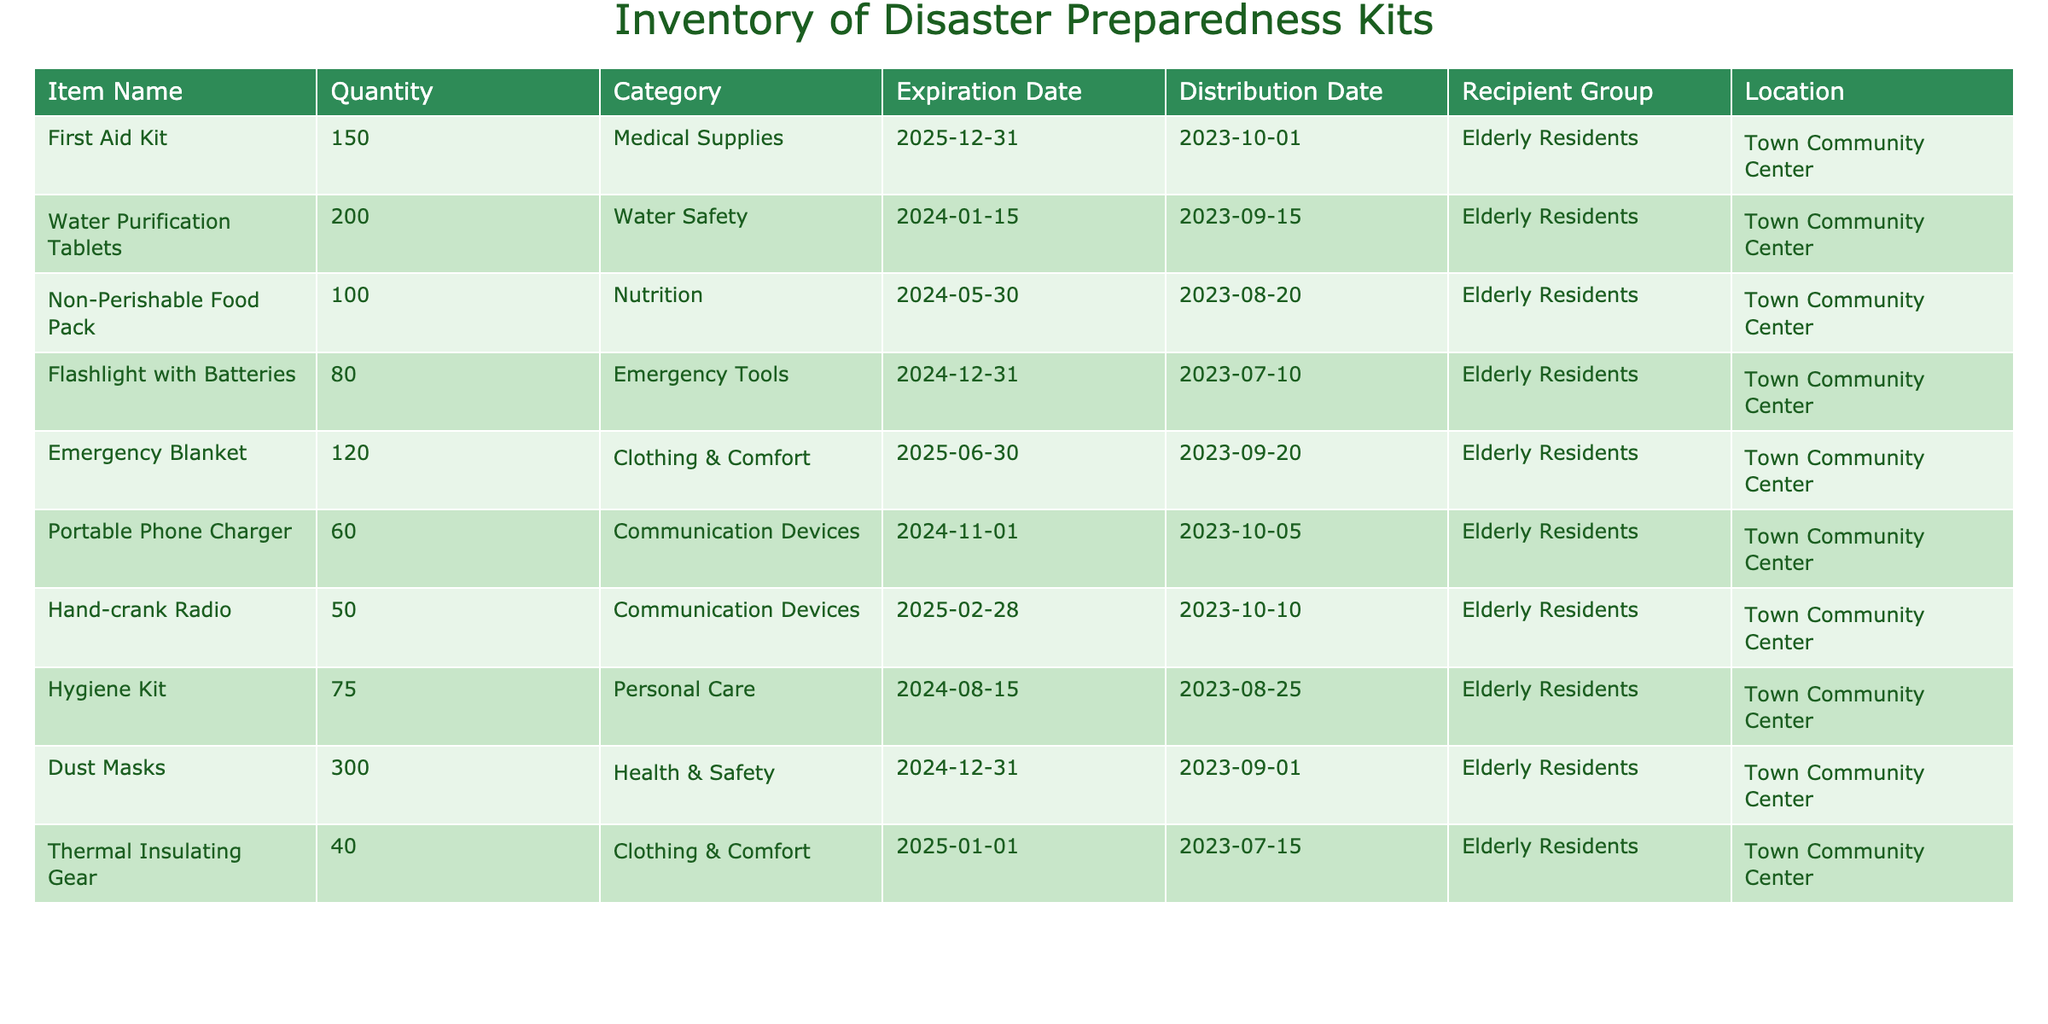What is the total quantity of Non-Perishable Food Packs distributed? The table shows that 100 Non-Perishable Food Packs were distributed to the Elderly Residents on the distribution date of 2023-08-20. Therefore, the answer is directly obtainable from the table.
Answer: 100 How many communication devices are in the inventory? There are two types of communication devices listed: Portable Phone Charger with a quantity of 60 and Hand-crank Radio with a quantity of 50. To find the total, we add these quantities: 60 + 50 = 110.
Answer: 110 Is there an Emergency Blanket in the inventory? The table lists Emergency Blankets among the distributed items with a quantity of 120 and specifies that it is categorized under Clothing & Comfort. Therefore, the answer is yes.
Answer: Yes What is the expiration date of the Water Purification Tablets? According to the table, the expiration date for Water Purification Tablets is 2024-01-15. This information is provided explicitly in the corresponding row of the table.
Answer: 2024-01-15 How many items in total were distributed to the Elderly Residents? To find the total, we need to sum the quantities from each item distributed to the Elderly Residents: 150 (First Aid Kit) + 200 (Water Purification Tablets) + 100 (Non-Perishable Food Pack) + 80 (Flashlight with Batteries) + 120 (Emergency Blanket) + 60 (Portable Phone Charger) + 50 (Hand-crank Radio) + 75 (Hygiene Kit) + 300 (Dust Masks) + 40 (Thermal Insulating Gear) = 975. Therefore, the total number of items is 975.
Answer: 975 How many more Dust Masks are there compared to Flashlights? From the table, we see there are 300 Dust Masks and 80 Flashlights. To find out how many more Dust Masks there are, we subtract the quantity of Flashlights from the Dust Masks: 300 - 80 = 220. This gives us the difference.
Answer: 220 Is the quantity of Hygiene Kits greater than all other items except Dust Masks? The table shows 75 Hygiene Kits, and comparing this with other items: First Aid Kit (150), Water Purification Tablets (200), Non-Perishable Food Pack (100), Flashlight (80), Emergency Blanket (120), Portable Phone Charger (60), Hand-crank Radio (50), and Thermal Insulating Gear (40), none have greater quantity than 75 except Dust Masks (300). Therefore, the answer to whether it is greater than all other items except Dust Masks is true.
Answer: Yes What is the distribution date of the Hand-crank Radio? The table indicates that the Hand-crank Radio was distributed on 2023-10-10. This information is clearly listed in the table under the corresponding item.
Answer: 2023-10-10 What is the total quantity of items categorized under Medical Supplies? There is only one item listed under Medical Supplies, which is the First Aid Kit with a quantity of 150. Since there are no other items in this category, the total is simply that quantity.
Answer: 150 